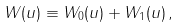<formula> <loc_0><loc_0><loc_500><loc_500>W ( u ) \equiv W _ { 0 } ( u ) + W _ { 1 } ( u ) \, ,</formula> 